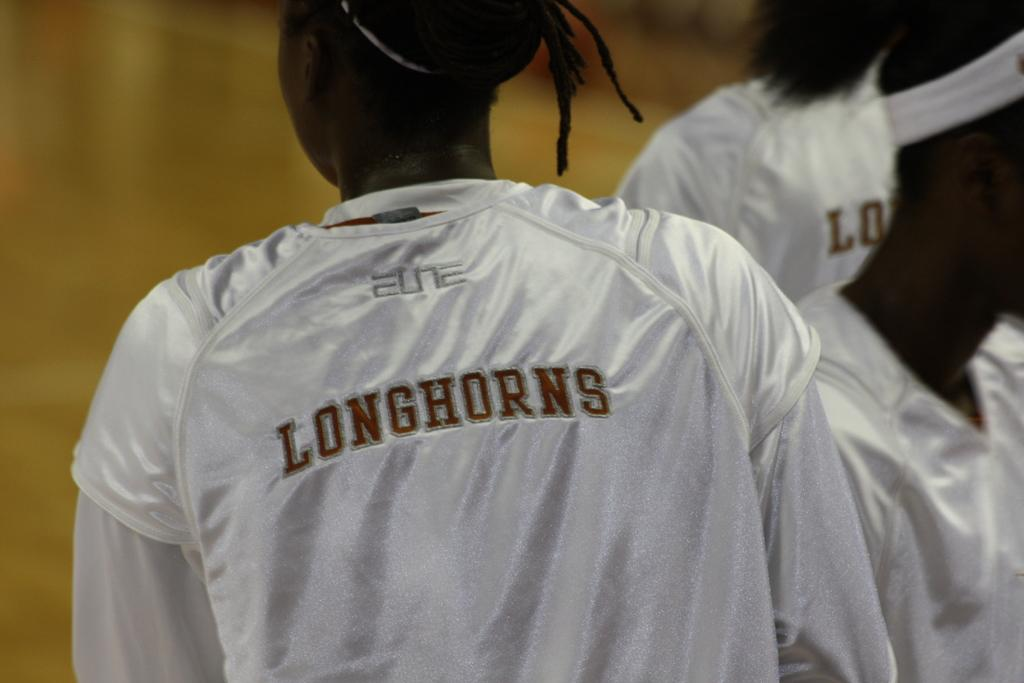<image>
Summarize the visual content of the image. A black athlete wearing a white jersey with Longhorns written on the back. 